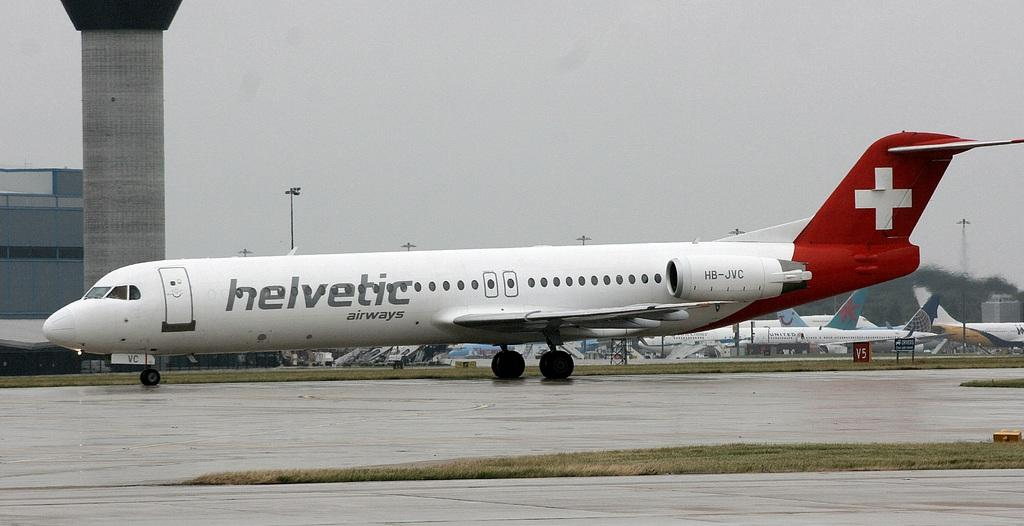<image>
Create a compact narrative representing the image presented. a helvetic airplane with a red cross symbol on the tail. 